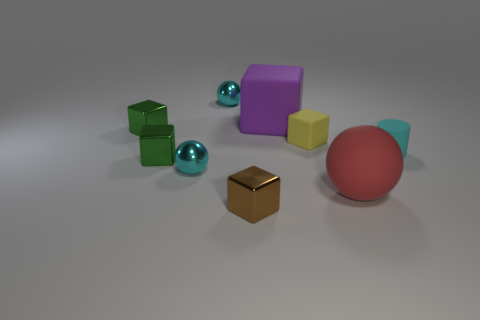Subtract 1 cubes. How many cubes are left? 4 Subtract all blue blocks. Subtract all blue spheres. How many blocks are left? 5 Subtract all balls. How many objects are left? 6 Subtract all cyan balls. Subtract all brown metal cubes. How many objects are left? 6 Add 6 tiny spheres. How many tiny spheres are left? 8 Add 4 yellow matte cubes. How many yellow matte cubes exist? 5 Subtract 0 red cylinders. How many objects are left? 9 